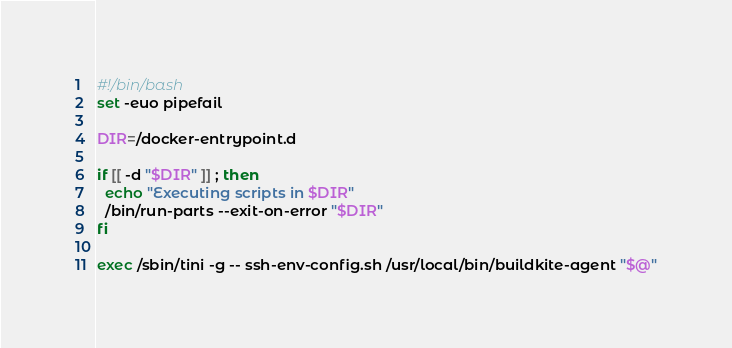<code> <loc_0><loc_0><loc_500><loc_500><_Bash_>#!/bin/bash
set -euo pipefail

DIR=/docker-entrypoint.d

if [[ -d "$DIR" ]] ; then
  echo "Executing scripts in $DIR"
  /bin/run-parts --exit-on-error "$DIR"
fi

exec /sbin/tini -g -- ssh-env-config.sh /usr/local/bin/buildkite-agent "$@"</code> 